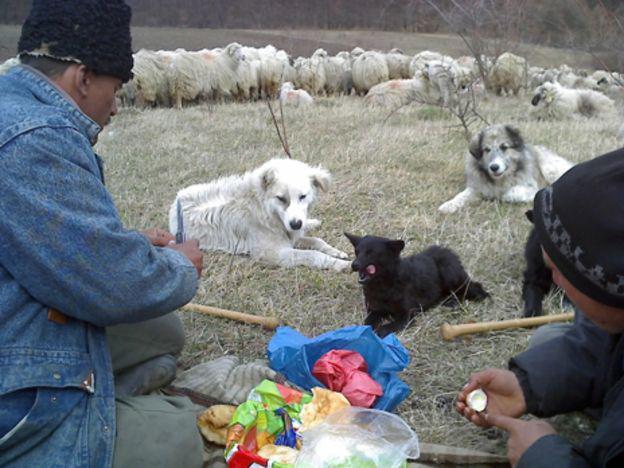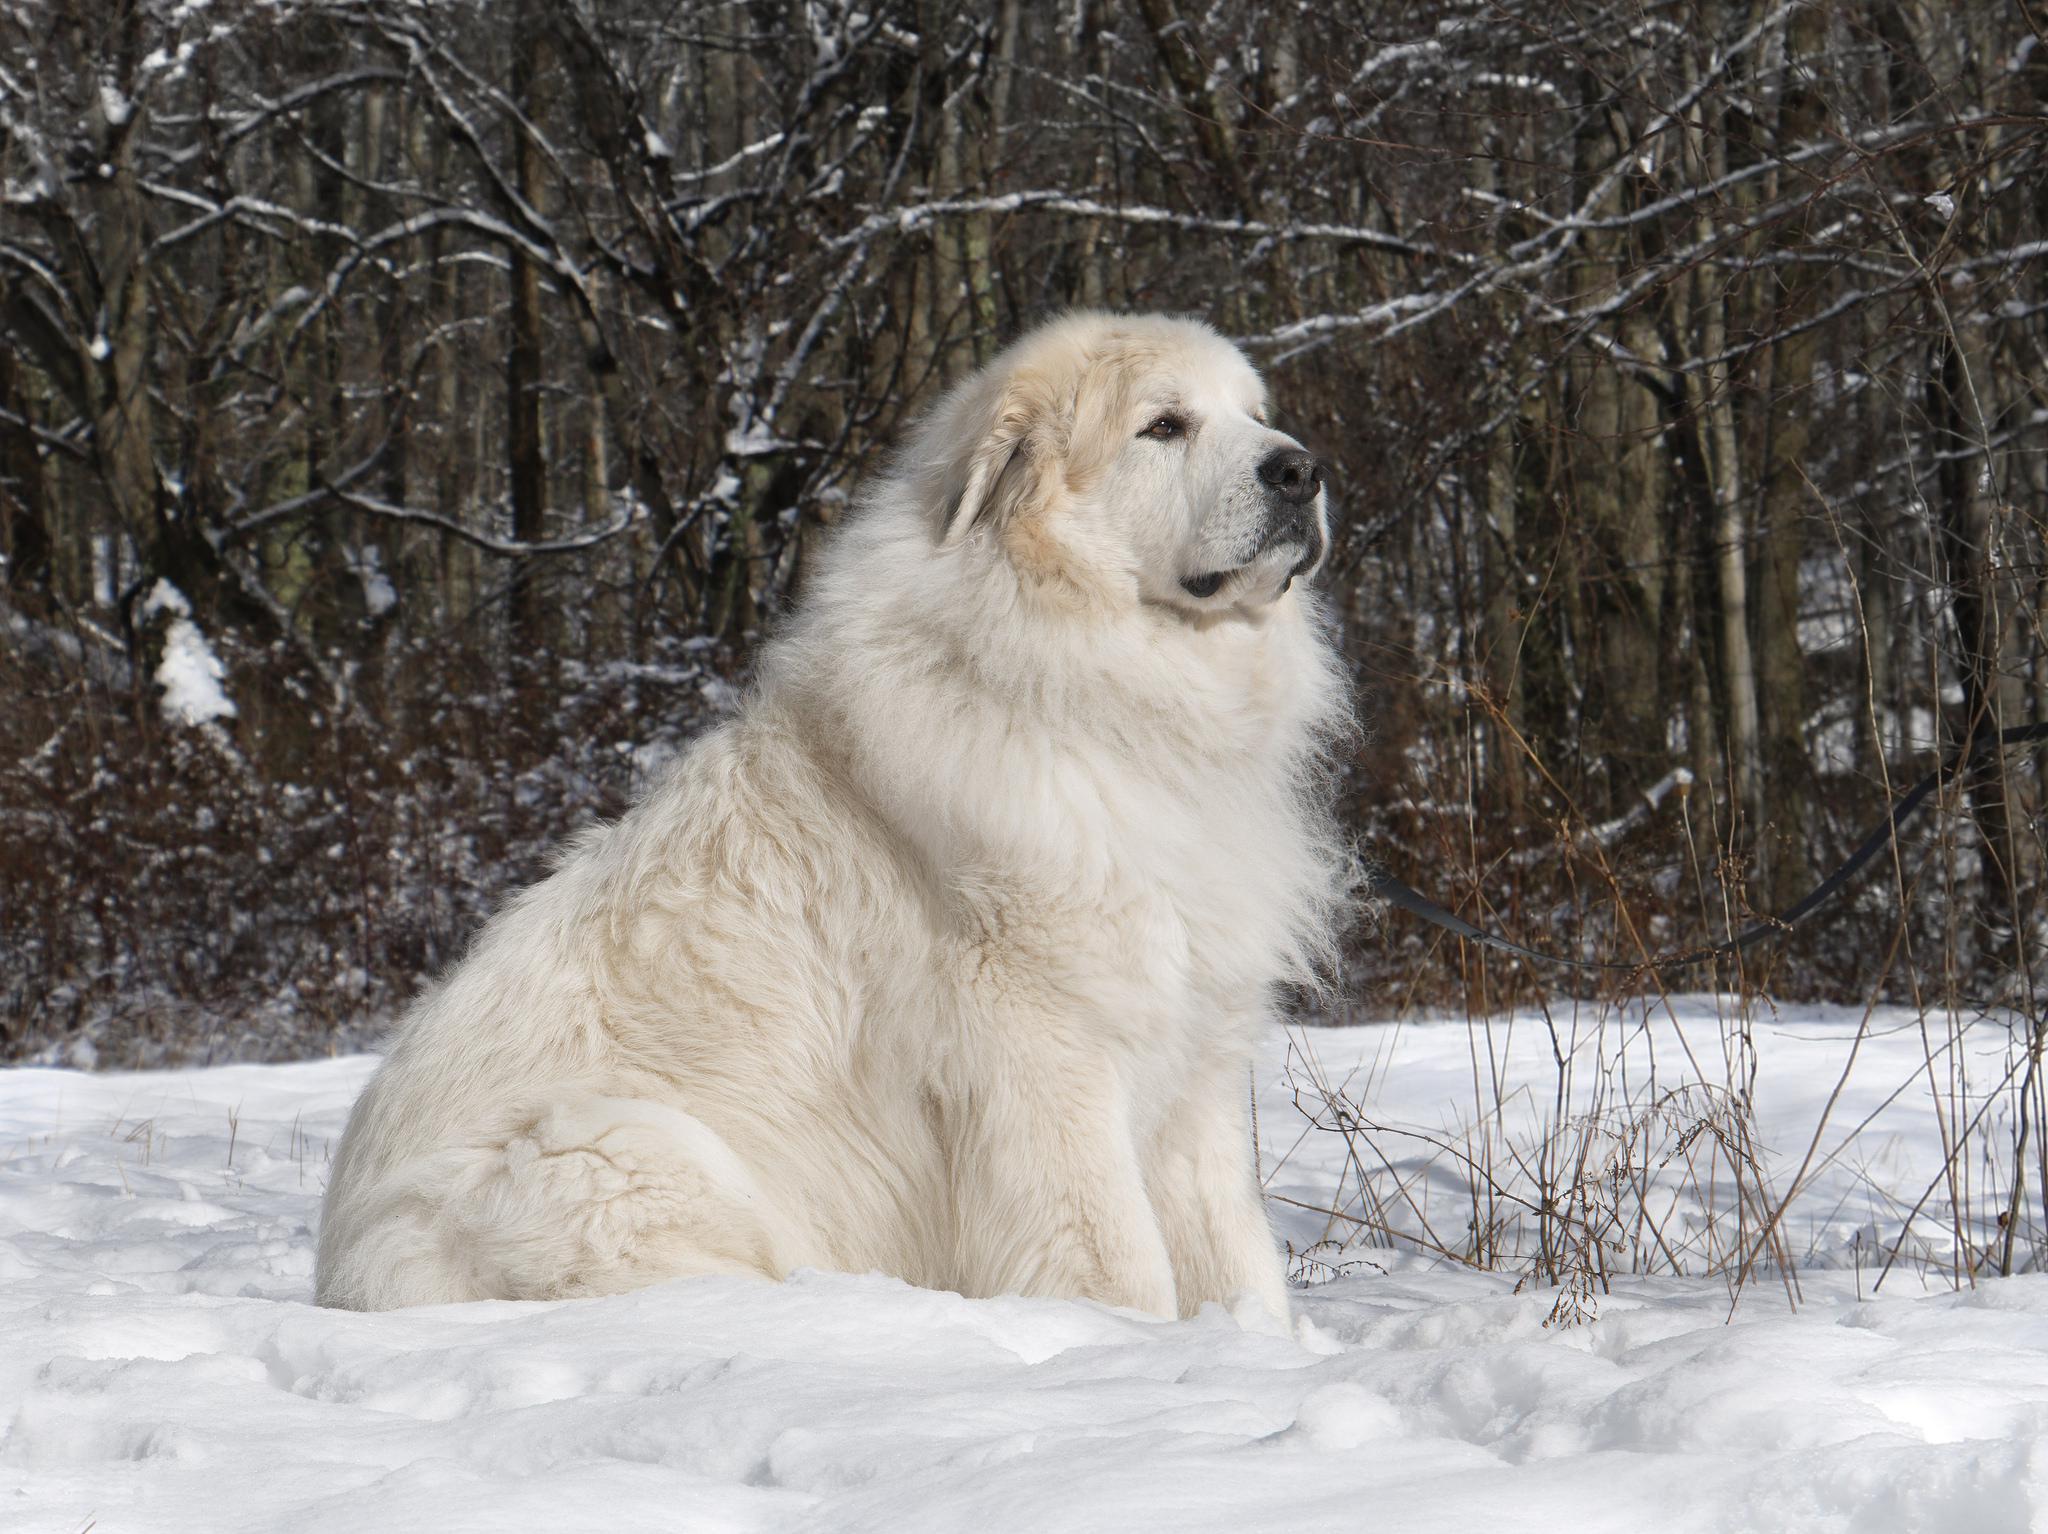The first image is the image on the left, the second image is the image on the right. For the images displayed, is the sentence "There is at least one human with the dogs." factually correct? Answer yes or no. Yes. 